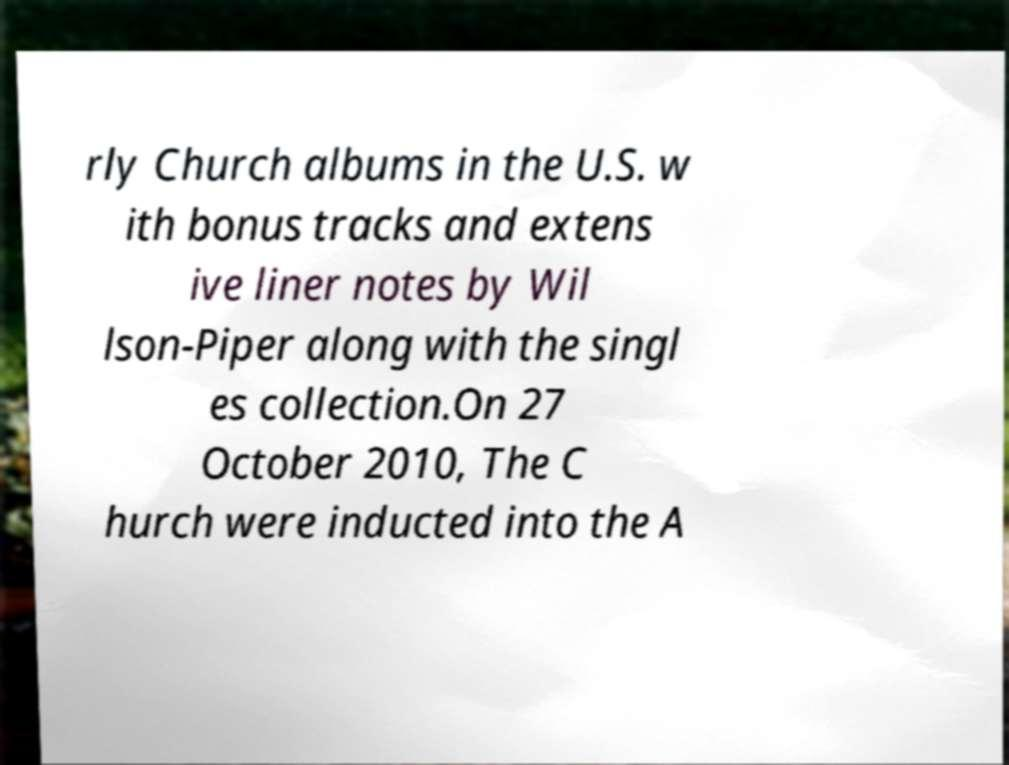Could you assist in decoding the text presented in this image and type it out clearly? rly Church albums in the U.S. w ith bonus tracks and extens ive liner notes by Wil lson-Piper along with the singl es collection.On 27 October 2010, The C hurch were inducted into the A 